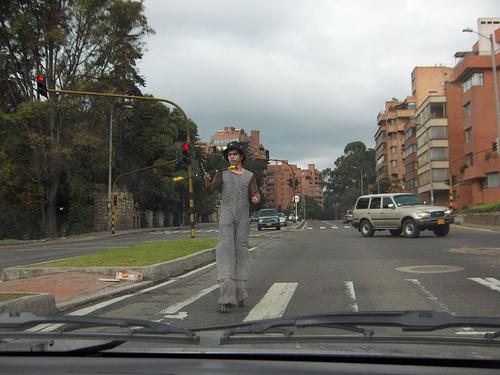Sunny or overcast?
Short answer required. Overcast. What shape is drawn on the street in white?
Write a very short answer. Rectangle. Is there a lot of traffic?
Write a very short answer. No. Is this in the USA?
Write a very short answer. Yes. What is driving lots of people?
Be succinct. Car. Is the skater risking traffic?
Keep it brief. Yes. What is on the street?
Concise answer only. Man. Is the man on stilts?
Be succinct. Yes. What is the weather like?
Be succinct. Cloudy. Who is directing traffic?
Short answer required. Clown. How many street lights are there?
Short answer required. 2. Is there a green tent in this picture?
Give a very brief answer. No. How many levels are on the vehicle?
Keep it brief. 1. Are the streets brick?
Concise answer only. No. Is the person going to fall?
Be succinct. No. What is the man doing?
Short answer required. Walking. What type of shoes is this man wearing?
Give a very brief answer. Stilts. How many vehicles are visible?
Answer briefly. 2. 